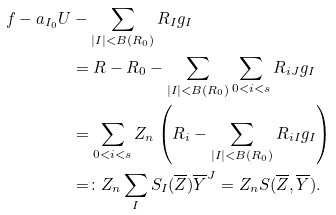Convert formula to latex. <formula><loc_0><loc_0><loc_500><loc_500>f - a _ { I _ { 0 } } U & - \sum _ { | I | < B ( R _ { 0 } ) } R _ { I } g _ { I } \\ & = R - R _ { 0 } - \sum _ { | I | < B ( R _ { 0 } ) } \sum _ { 0 < i < s } R _ { i J } g _ { I } \\ & = \sum _ { 0 < i < s } Z _ { n } \left ( R _ { i } - \sum _ { | I | < B ( R _ { 0 } ) } R _ { i I } g _ { I } \right ) \\ & = \colon Z _ { n } \sum _ { I } S _ { I } ( \overline { Z } ) \overline { Y } ^ { J } = Z _ { n } S ( \overline { Z } , \overline { Y } ) .</formula> 